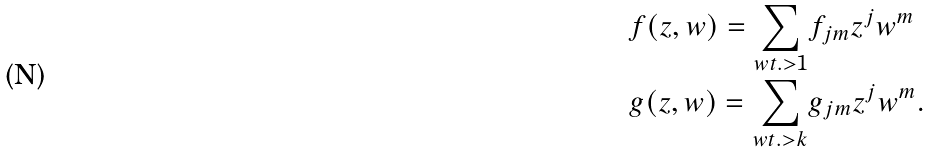Convert formula to latex. <formula><loc_0><loc_0><loc_500><loc_500>f ( z , w ) = \sum _ { w t . > 1 } & f _ { j m } z ^ { j } w ^ { m } \\ g ( z , w ) = \sum _ { w t . > k } & g _ { j m } z ^ { j } w ^ { m } . \\</formula> 